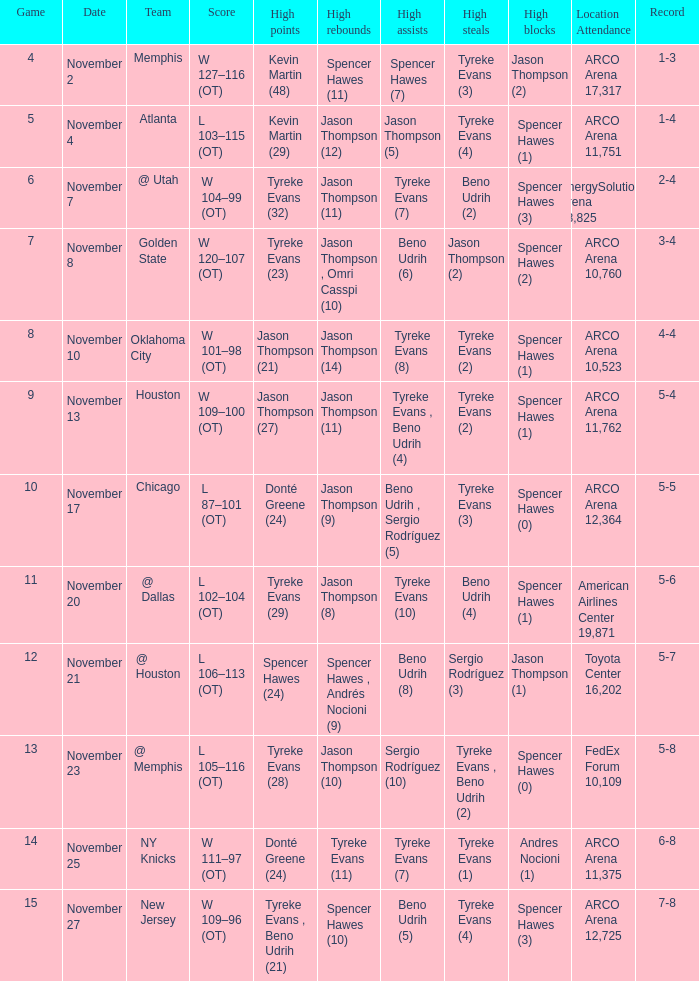Write the full table. {'header': ['Game', 'Date', 'Team', 'Score', 'High points', 'High rebounds', 'High assists', 'High steals', 'High blocks', 'Location Attendance', 'Record'], 'rows': [['4', 'November 2', 'Memphis', 'W 127–116 (OT)', 'Kevin Martin (48)', 'Spencer Hawes (11)', 'Spencer Hawes (7)', 'Tyreke Evans (3)', 'Jason Thompson (2)', 'ARCO Arena 17,317', '1-3'], ['5', 'November 4', 'Atlanta', 'L 103–115 (OT)', 'Kevin Martin (29)', 'Jason Thompson (12)', 'Jason Thompson (5)', 'Tyreke Evans (4)', 'Spencer Hawes (1)', 'ARCO Arena 11,751', '1-4'], ['6', 'November 7', '@ Utah', 'W 104–99 (OT)', 'Tyreke Evans (32)', 'Jason Thompson (11)', 'Tyreke Evans (7)', 'Beno Udrih (2)', 'Spencer Hawes (3)', 'EnergySolutions Arena 18,825', '2-4'], ['7', 'November 8', 'Golden State', 'W 120–107 (OT)', 'Tyreke Evans (23)', 'Jason Thompson , Omri Casspi (10)', 'Beno Udrih (6)', 'Jason Thompson (2)', 'Spencer Hawes (2)', 'ARCO Arena 10,760', '3-4'], ['8', 'November 10', 'Oklahoma City', 'W 101–98 (OT)', 'Jason Thompson (21)', 'Jason Thompson (14)', 'Tyreke Evans (8)', 'Tyreke Evans (2)', 'Spencer Hawes (1)', 'ARCO Arena 10,523', '4-4'], ['9', 'November 13', 'Houston', 'W 109–100 (OT)', 'Jason Thompson (27)', 'Jason Thompson (11)', 'Tyreke Evans , Beno Udrih (4)', 'Tyreke Evans (2)', 'Spencer Hawes (1)', 'ARCO Arena 11,762', '5-4'], ['10', 'November 17', 'Chicago', 'L 87–101 (OT)', 'Donté Greene (24)', 'Jason Thompson (9)', 'Beno Udrih , Sergio Rodríguez (5)', 'Tyreke Evans (3)', 'Spencer Hawes (0)', 'ARCO Arena 12,364', '5-5'], ['11', 'November 20', '@ Dallas', 'L 102–104 (OT)', 'Tyreke Evans (29)', 'Jason Thompson (8)', 'Tyreke Evans (10)', 'Beno Udrih (4)', 'Spencer Hawes (1)', 'American Airlines Center 19,871', '5-6'], ['12', 'November 21', '@ Houston', 'L 106–113 (OT)', 'Spencer Hawes (24)', 'Spencer Hawes , Andrés Nocioni (9)', 'Beno Udrih (8)', 'Sergio Rodríguez (3)', 'Jason Thompson (1)', 'Toyota Center 16,202', '5-7'], ['13', 'November 23', '@ Memphis', 'L 105–116 (OT)', 'Tyreke Evans (28)', 'Jason Thompson (10)', 'Sergio Rodríguez (10)', 'Tyreke Evans , Beno Udrih (2)', 'Spencer Hawes (0)', 'FedEx Forum 10,109', '5-8'], ['14', 'November 25', 'NY Knicks', 'W 111–97 (OT)', 'Donté Greene (24)', 'Tyreke Evans (11)', 'Tyreke Evans (7)', 'Tyreke Evans (1)', 'Andres Nocioni (1)', 'ARCO Arena 11,375', '6-8'], ['15', 'November 27', 'New Jersey', 'W 109–96 (OT)', 'Tyreke Evans , Beno Udrih (21)', 'Spencer Hawes (10)', 'Beno Udrih (5)', 'Tyreke Evans (4)', 'Spencer Hawes (3)', 'ARCO Arena 12,725', '7-8']]} If the record is 6-8, what was the score? W 111–97 (OT). 